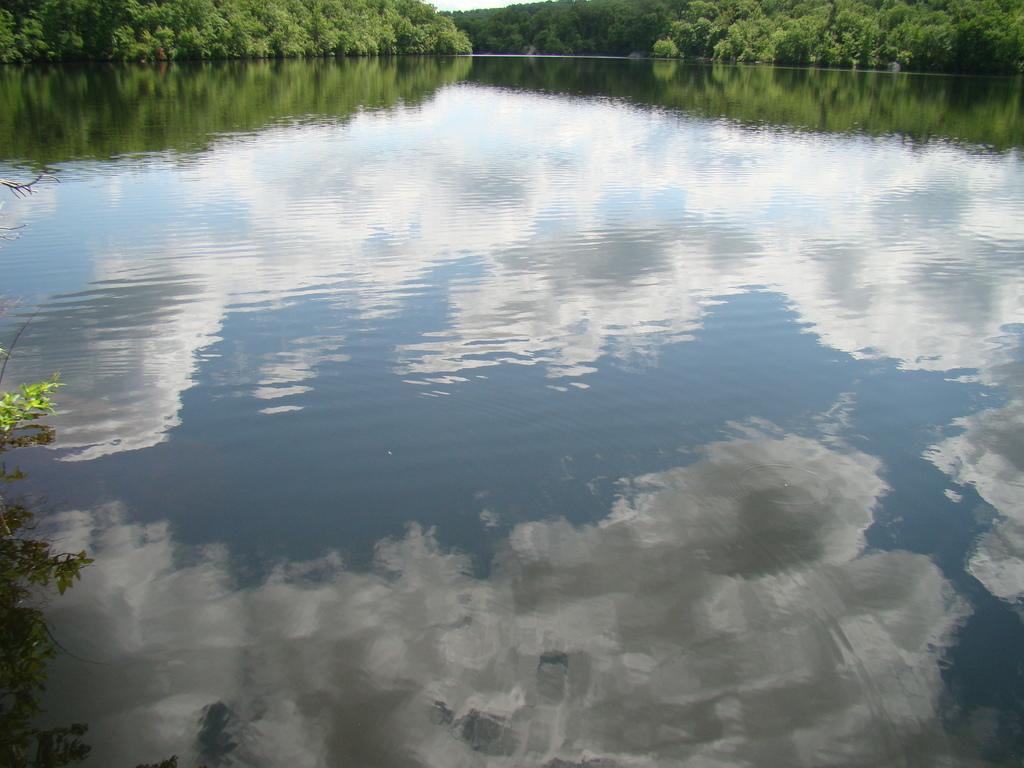Can you describe this image briefly? In the image I can the reflection of clouds in the water and around there are some trees and plants. 